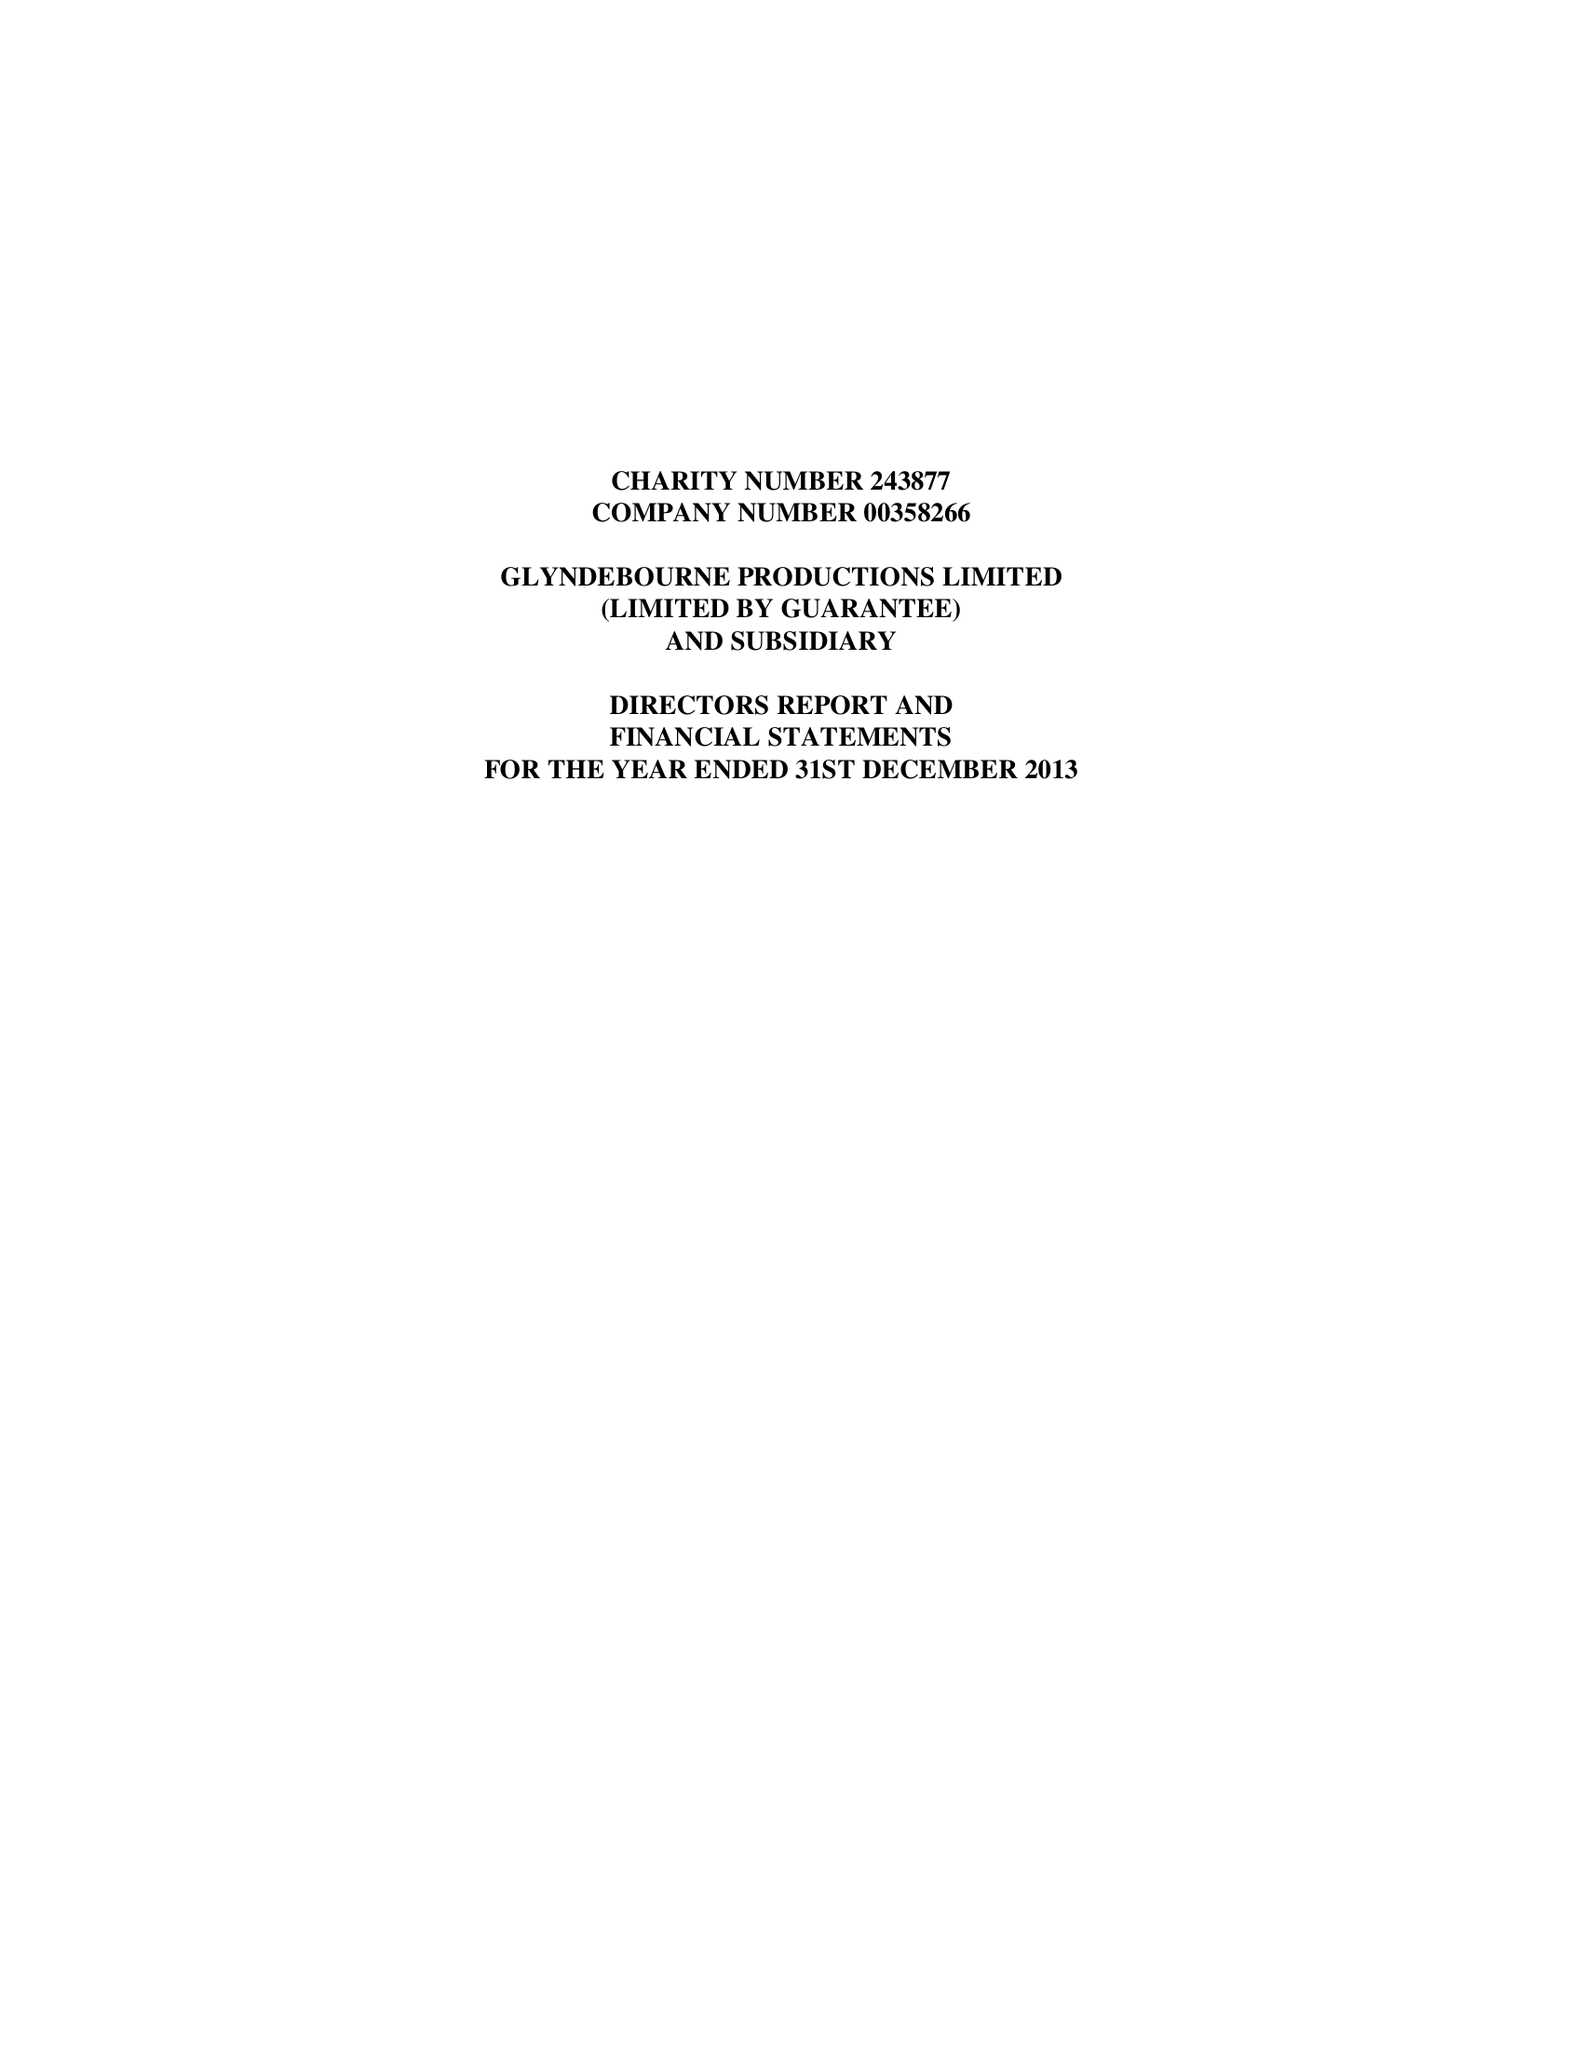What is the value for the address__postcode?
Answer the question using a single word or phrase. BN8 5UU 